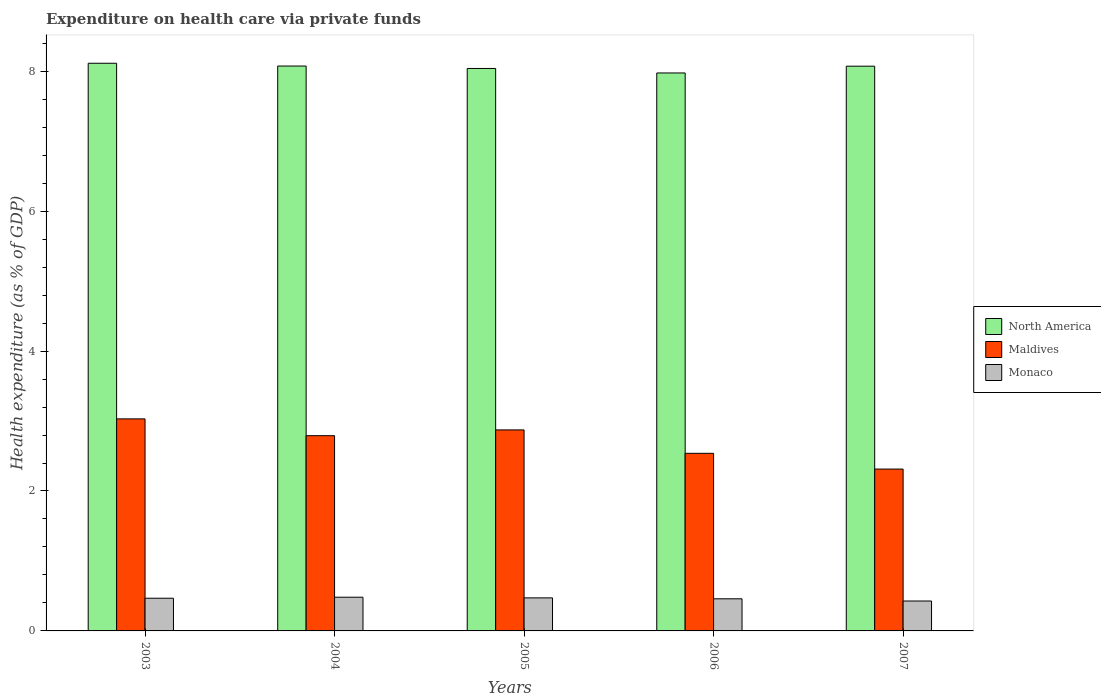How many groups of bars are there?
Make the answer very short. 5. Are the number of bars per tick equal to the number of legend labels?
Offer a terse response. Yes. How many bars are there on the 2nd tick from the left?
Offer a very short reply. 3. What is the expenditure made on health care in Maldives in 2004?
Your answer should be compact. 2.79. Across all years, what is the maximum expenditure made on health care in North America?
Provide a short and direct response. 8.11. Across all years, what is the minimum expenditure made on health care in Monaco?
Give a very brief answer. 0.43. What is the total expenditure made on health care in Monaco in the graph?
Your answer should be very brief. 2.31. What is the difference between the expenditure made on health care in Maldives in 2004 and that in 2007?
Offer a very short reply. 0.48. What is the difference between the expenditure made on health care in North America in 2003 and the expenditure made on health care in Monaco in 2004?
Keep it short and to the point. 7.63. What is the average expenditure made on health care in Maldives per year?
Give a very brief answer. 2.71. In the year 2004, what is the difference between the expenditure made on health care in North America and expenditure made on health care in Monaco?
Ensure brevity in your answer.  7.59. What is the ratio of the expenditure made on health care in Monaco in 2003 to that in 2005?
Make the answer very short. 0.99. Is the expenditure made on health care in Monaco in 2003 less than that in 2006?
Offer a very short reply. No. What is the difference between the highest and the second highest expenditure made on health care in Monaco?
Your answer should be compact. 0.01. What is the difference between the highest and the lowest expenditure made on health care in Monaco?
Make the answer very short. 0.05. In how many years, is the expenditure made on health care in North America greater than the average expenditure made on health care in North America taken over all years?
Your response must be concise. 3. What does the 2nd bar from the left in 2007 represents?
Provide a short and direct response. Maldives. What does the 1st bar from the right in 2006 represents?
Make the answer very short. Monaco. Are all the bars in the graph horizontal?
Your answer should be very brief. No. Does the graph contain any zero values?
Your answer should be compact. No. Where does the legend appear in the graph?
Make the answer very short. Center right. How are the legend labels stacked?
Provide a succinct answer. Vertical. What is the title of the graph?
Make the answer very short. Expenditure on health care via private funds. Does "Albania" appear as one of the legend labels in the graph?
Your response must be concise. No. What is the label or title of the X-axis?
Your answer should be compact. Years. What is the label or title of the Y-axis?
Keep it short and to the point. Health expenditure (as % of GDP). What is the Health expenditure (as % of GDP) of North America in 2003?
Your answer should be very brief. 8.11. What is the Health expenditure (as % of GDP) of Maldives in 2003?
Make the answer very short. 3.03. What is the Health expenditure (as % of GDP) of Monaco in 2003?
Provide a succinct answer. 0.47. What is the Health expenditure (as % of GDP) of North America in 2004?
Offer a very short reply. 8.07. What is the Health expenditure (as % of GDP) in Maldives in 2004?
Offer a very short reply. 2.79. What is the Health expenditure (as % of GDP) of Monaco in 2004?
Make the answer very short. 0.48. What is the Health expenditure (as % of GDP) in North America in 2005?
Offer a very short reply. 8.04. What is the Health expenditure (as % of GDP) in Maldives in 2005?
Offer a very short reply. 2.87. What is the Health expenditure (as % of GDP) of Monaco in 2005?
Ensure brevity in your answer.  0.47. What is the Health expenditure (as % of GDP) of North America in 2006?
Your answer should be very brief. 7.98. What is the Health expenditure (as % of GDP) in Maldives in 2006?
Offer a very short reply. 2.54. What is the Health expenditure (as % of GDP) of Monaco in 2006?
Provide a short and direct response. 0.46. What is the Health expenditure (as % of GDP) in North America in 2007?
Your response must be concise. 8.07. What is the Health expenditure (as % of GDP) in Maldives in 2007?
Offer a terse response. 2.31. What is the Health expenditure (as % of GDP) in Monaco in 2007?
Provide a succinct answer. 0.43. Across all years, what is the maximum Health expenditure (as % of GDP) of North America?
Keep it short and to the point. 8.11. Across all years, what is the maximum Health expenditure (as % of GDP) of Maldives?
Offer a terse response. 3.03. Across all years, what is the maximum Health expenditure (as % of GDP) in Monaco?
Provide a short and direct response. 0.48. Across all years, what is the minimum Health expenditure (as % of GDP) of North America?
Ensure brevity in your answer.  7.98. Across all years, what is the minimum Health expenditure (as % of GDP) of Maldives?
Provide a short and direct response. 2.31. Across all years, what is the minimum Health expenditure (as % of GDP) in Monaco?
Provide a succinct answer. 0.43. What is the total Health expenditure (as % of GDP) in North America in the graph?
Offer a very short reply. 40.27. What is the total Health expenditure (as % of GDP) of Maldives in the graph?
Keep it short and to the point. 13.55. What is the total Health expenditure (as % of GDP) in Monaco in the graph?
Ensure brevity in your answer.  2.31. What is the difference between the Health expenditure (as % of GDP) of North America in 2003 and that in 2004?
Offer a very short reply. 0.04. What is the difference between the Health expenditure (as % of GDP) in Maldives in 2003 and that in 2004?
Keep it short and to the point. 0.24. What is the difference between the Health expenditure (as % of GDP) of Monaco in 2003 and that in 2004?
Your answer should be compact. -0.01. What is the difference between the Health expenditure (as % of GDP) in North America in 2003 and that in 2005?
Your response must be concise. 0.07. What is the difference between the Health expenditure (as % of GDP) in Maldives in 2003 and that in 2005?
Provide a succinct answer. 0.16. What is the difference between the Health expenditure (as % of GDP) of Monaco in 2003 and that in 2005?
Your answer should be very brief. -0.01. What is the difference between the Health expenditure (as % of GDP) of North America in 2003 and that in 2006?
Your answer should be compact. 0.14. What is the difference between the Health expenditure (as % of GDP) of Maldives in 2003 and that in 2006?
Ensure brevity in your answer.  0.49. What is the difference between the Health expenditure (as % of GDP) in Monaco in 2003 and that in 2006?
Your answer should be very brief. 0.01. What is the difference between the Health expenditure (as % of GDP) of North America in 2003 and that in 2007?
Give a very brief answer. 0.04. What is the difference between the Health expenditure (as % of GDP) of Maldives in 2003 and that in 2007?
Offer a terse response. 0.72. What is the difference between the Health expenditure (as % of GDP) of Monaco in 2003 and that in 2007?
Your answer should be compact. 0.04. What is the difference between the Health expenditure (as % of GDP) of North America in 2004 and that in 2005?
Offer a very short reply. 0.03. What is the difference between the Health expenditure (as % of GDP) of Maldives in 2004 and that in 2005?
Provide a succinct answer. -0.08. What is the difference between the Health expenditure (as % of GDP) in Monaco in 2004 and that in 2005?
Offer a terse response. 0.01. What is the difference between the Health expenditure (as % of GDP) in North America in 2004 and that in 2006?
Keep it short and to the point. 0.1. What is the difference between the Health expenditure (as % of GDP) in Maldives in 2004 and that in 2006?
Ensure brevity in your answer.  0.25. What is the difference between the Health expenditure (as % of GDP) of Monaco in 2004 and that in 2006?
Offer a very short reply. 0.02. What is the difference between the Health expenditure (as % of GDP) in North America in 2004 and that in 2007?
Offer a terse response. 0. What is the difference between the Health expenditure (as % of GDP) in Maldives in 2004 and that in 2007?
Your answer should be compact. 0.48. What is the difference between the Health expenditure (as % of GDP) of Monaco in 2004 and that in 2007?
Provide a short and direct response. 0.05. What is the difference between the Health expenditure (as % of GDP) of North America in 2005 and that in 2006?
Give a very brief answer. 0.06. What is the difference between the Health expenditure (as % of GDP) of Maldives in 2005 and that in 2006?
Your answer should be compact. 0.33. What is the difference between the Health expenditure (as % of GDP) in Monaco in 2005 and that in 2006?
Offer a very short reply. 0.01. What is the difference between the Health expenditure (as % of GDP) in North America in 2005 and that in 2007?
Offer a terse response. -0.03. What is the difference between the Health expenditure (as % of GDP) in Maldives in 2005 and that in 2007?
Make the answer very short. 0.56. What is the difference between the Health expenditure (as % of GDP) in Monaco in 2005 and that in 2007?
Your response must be concise. 0.04. What is the difference between the Health expenditure (as % of GDP) of North America in 2006 and that in 2007?
Your answer should be very brief. -0.1. What is the difference between the Health expenditure (as % of GDP) of Maldives in 2006 and that in 2007?
Provide a succinct answer. 0.23. What is the difference between the Health expenditure (as % of GDP) in Monaco in 2006 and that in 2007?
Your response must be concise. 0.03. What is the difference between the Health expenditure (as % of GDP) in North America in 2003 and the Health expenditure (as % of GDP) in Maldives in 2004?
Offer a terse response. 5.32. What is the difference between the Health expenditure (as % of GDP) in North America in 2003 and the Health expenditure (as % of GDP) in Monaco in 2004?
Your response must be concise. 7.63. What is the difference between the Health expenditure (as % of GDP) of Maldives in 2003 and the Health expenditure (as % of GDP) of Monaco in 2004?
Offer a terse response. 2.55. What is the difference between the Health expenditure (as % of GDP) in North America in 2003 and the Health expenditure (as % of GDP) in Maldives in 2005?
Ensure brevity in your answer.  5.24. What is the difference between the Health expenditure (as % of GDP) in North America in 2003 and the Health expenditure (as % of GDP) in Monaco in 2005?
Provide a succinct answer. 7.64. What is the difference between the Health expenditure (as % of GDP) in Maldives in 2003 and the Health expenditure (as % of GDP) in Monaco in 2005?
Provide a succinct answer. 2.56. What is the difference between the Health expenditure (as % of GDP) in North America in 2003 and the Health expenditure (as % of GDP) in Maldives in 2006?
Provide a short and direct response. 5.58. What is the difference between the Health expenditure (as % of GDP) of North America in 2003 and the Health expenditure (as % of GDP) of Monaco in 2006?
Give a very brief answer. 7.65. What is the difference between the Health expenditure (as % of GDP) in Maldives in 2003 and the Health expenditure (as % of GDP) in Monaco in 2006?
Your answer should be compact. 2.57. What is the difference between the Health expenditure (as % of GDP) in North America in 2003 and the Health expenditure (as % of GDP) in Maldives in 2007?
Your answer should be very brief. 5.8. What is the difference between the Health expenditure (as % of GDP) of North America in 2003 and the Health expenditure (as % of GDP) of Monaco in 2007?
Make the answer very short. 7.69. What is the difference between the Health expenditure (as % of GDP) in Maldives in 2003 and the Health expenditure (as % of GDP) in Monaco in 2007?
Provide a succinct answer. 2.6. What is the difference between the Health expenditure (as % of GDP) in North America in 2004 and the Health expenditure (as % of GDP) in Maldives in 2005?
Your answer should be very brief. 5.2. What is the difference between the Health expenditure (as % of GDP) in North America in 2004 and the Health expenditure (as % of GDP) in Monaco in 2005?
Provide a succinct answer. 7.6. What is the difference between the Health expenditure (as % of GDP) in Maldives in 2004 and the Health expenditure (as % of GDP) in Monaco in 2005?
Provide a succinct answer. 2.32. What is the difference between the Health expenditure (as % of GDP) of North America in 2004 and the Health expenditure (as % of GDP) of Maldives in 2006?
Make the answer very short. 5.54. What is the difference between the Health expenditure (as % of GDP) in North America in 2004 and the Health expenditure (as % of GDP) in Monaco in 2006?
Your answer should be compact. 7.62. What is the difference between the Health expenditure (as % of GDP) of Maldives in 2004 and the Health expenditure (as % of GDP) of Monaco in 2006?
Offer a terse response. 2.33. What is the difference between the Health expenditure (as % of GDP) of North America in 2004 and the Health expenditure (as % of GDP) of Maldives in 2007?
Provide a short and direct response. 5.76. What is the difference between the Health expenditure (as % of GDP) in North America in 2004 and the Health expenditure (as % of GDP) in Monaco in 2007?
Your answer should be very brief. 7.65. What is the difference between the Health expenditure (as % of GDP) in Maldives in 2004 and the Health expenditure (as % of GDP) in Monaco in 2007?
Provide a short and direct response. 2.36. What is the difference between the Health expenditure (as % of GDP) of North America in 2005 and the Health expenditure (as % of GDP) of Maldives in 2006?
Offer a very short reply. 5.5. What is the difference between the Health expenditure (as % of GDP) in North America in 2005 and the Health expenditure (as % of GDP) in Monaco in 2006?
Your answer should be compact. 7.58. What is the difference between the Health expenditure (as % of GDP) of Maldives in 2005 and the Health expenditure (as % of GDP) of Monaco in 2006?
Your response must be concise. 2.41. What is the difference between the Health expenditure (as % of GDP) in North America in 2005 and the Health expenditure (as % of GDP) in Maldives in 2007?
Keep it short and to the point. 5.73. What is the difference between the Health expenditure (as % of GDP) in North America in 2005 and the Health expenditure (as % of GDP) in Monaco in 2007?
Give a very brief answer. 7.61. What is the difference between the Health expenditure (as % of GDP) in Maldives in 2005 and the Health expenditure (as % of GDP) in Monaco in 2007?
Your answer should be very brief. 2.45. What is the difference between the Health expenditure (as % of GDP) in North America in 2006 and the Health expenditure (as % of GDP) in Maldives in 2007?
Your answer should be compact. 5.66. What is the difference between the Health expenditure (as % of GDP) in North America in 2006 and the Health expenditure (as % of GDP) in Monaco in 2007?
Your answer should be very brief. 7.55. What is the difference between the Health expenditure (as % of GDP) of Maldives in 2006 and the Health expenditure (as % of GDP) of Monaco in 2007?
Keep it short and to the point. 2.11. What is the average Health expenditure (as % of GDP) of North America per year?
Keep it short and to the point. 8.05. What is the average Health expenditure (as % of GDP) in Maldives per year?
Offer a terse response. 2.71. What is the average Health expenditure (as % of GDP) of Monaco per year?
Your answer should be very brief. 0.46. In the year 2003, what is the difference between the Health expenditure (as % of GDP) of North America and Health expenditure (as % of GDP) of Maldives?
Ensure brevity in your answer.  5.08. In the year 2003, what is the difference between the Health expenditure (as % of GDP) in North America and Health expenditure (as % of GDP) in Monaco?
Your answer should be compact. 7.65. In the year 2003, what is the difference between the Health expenditure (as % of GDP) of Maldives and Health expenditure (as % of GDP) of Monaco?
Keep it short and to the point. 2.56. In the year 2004, what is the difference between the Health expenditure (as % of GDP) in North America and Health expenditure (as % of GDP) in Maldives?
Provide a succinct answer. 5.28. In the year 2004, what is the difference between the Health expenditure (as % of GDP) in North America and Health expenditure (as % of GDP) in Monaco?
Your answer should be very brief. 7.59. In the year 2004, what is the difference between the Health expenditure (as % of GDP) of Maldives and Health expenditure (as % of GDP) of Monaco?
Provide a succinct answer. 2.31. In the year 2005, what is the difference between the Health expenditure (as % of GDP) of North America and Health expenditure (as % of GDP) of Maldives?
Provide a short and direct response. 5.17. In the year 2005, what is the difference between the Health expenditure (as % of GDP) in North America and Health expenditure (as % of GDP) in Monaco?
Provide a succinct answer. 7.57. In the year 2005, what is the difference between the Health expenditure (as % of GDP) of Maldives and Health expenditure (as % of GDP) of Monaco?
Make the answer very short. 2.4. In the year 2006, what is the difference between the Health expenditure (as % of GDP) of North America and Health expenditure (as % of GDP) of Maldives?
Ensure brevity in your answer.  5.44. In the year 2006, what is the difference between the Health expenditure (as % of GDP) in North America and Health expenditure (as % of GDP) in Monaco?
Provide a short and direct response. 7.52. In the year 2006, what is the difference between the Health expenditure (as % of GDP) in Maldives and Health expenditure (as % of GDP) in Monaco?
Your answer should be very brief. 2.08. In the year 2007, what is the difference between the Health expenditure (as % of GDP) in North America and Health expenditure (as % of GDP) in Maldives?
Keep it short and to the point. 5.76. In the year 2007, what is the difference between the Health expenditure (as % of GDP) in North America and Health expenditure (as % of GDP) in Monaco?
Offer a very short reply. 7.64. In the year 2007, what is the difference between the Health expenditure (as % of GDP) of Maldives and Health expenditure (as % of GDP) of Monaco?
Your answer should be very brief. 1.89. What is the ratio of the Health expenditure (as % of GDP) in North America in 2003 to that in 2004?
Provide a short and direct response. 1. What is the ratio of the Health expenditure (as % of GDP) of Maldives in 2003 to that in 2004?
Provide a short and direct response. 1.09. What is the ratio of the Health expenditure (as % of GDP) in Monaco in 2003 to that in 2004?
Your response must be concise. 0.97. What is the ratio of the Health expenditure (as % of GDP) of North America in 2003 to that in 2005?
Offer a very short reply. 1.01. What is the ratio of the Health expenditure (as % of GDP) in Maldives in 2003 to that in 2005?
Your response must be concise. 1.05. What is the ratio of the Health expenditure (as % of GDP) in North America in 2003 to that in 2006?
Provide a short and direct response. 1.02. What is the ratio of the Health expenditure (as % of GDP) in Maldives in 2003 to that in 2006?
Give a very brief answer. 1.19. What is the ratio of the Health expenditure (as % of GDP) in Monaco in 2003 to that in 2006?
Ensure brevity in your answer.  1.02. What is the ratio of the Health expenditure (as % of GDP) in Maldives in 2003 to that in 2007?
Offer a very short reply. 1.31. What is the ratio of the Health expenditure (as % of GDP) of Monaco in 2003 to that in 2007?
Your answer should be compact. 1.09. What is the ratio of the Health expenditure (as % of GDP) in Maldives in 2004 to that in 2005?
Offer a terse response. 0.97. What is the ratio of the Health expenditure (as % of GDP) of Monaco in 2004 to that in 2005?
Your answer should be very brief. 1.02. What is the ratio of the Health expenditure (as % of GDP) of North America in 2004 to that in 2006?
Offer a very short reply. 1.01. What is the ratio of the Health expenditure (as % of GDP) of Maldives in 2004 to that in 2006?
Your answer should be very brief. 1.1. What is the ratio of the Health expenditure (as % of GDP) in Monaco in 2004 to that in 2006?
Your response must be concise. 1.05. What is the ratio of the Health expenditure (as % of GDP) in North America in 2004 to that in 2007?
Your response must be concise. 1. What is the ratio of the Health expenditure (as % of GDP) of Maldives in 2004 to that in 2007?
Your response must be concise. 1.21. What is the ratio of the Health expenditure (as % of GDP) in Monaco in 2004 to that in 2007?
Keep it short and to the point. 1.13. What is the ratio of the Health expenditure (as % of GDP) in Maldives in 2005 to that in 2006?
Provide a succinct answer. 1.13. What is the ratio of the Health expenditure (as % of GDP) in Monaco in 2005 to that in 2006?
Ensure brevity in your answer.  1.03. What is the ratio of the Health expenditure (as % of GDP) of North America in 2005 to that in 2007?
Offer a very short reply. 1. What is the ratio of the Health expenditure (as % of GDP) of Maldives in 2005 to that in 2007?
Provide a short and direct response. 1.24. What is the ratio of the Health expenditure (as % of GDP) of Monaco in 2005 to that in 2007?
Keep it short and to the point. 1.1. What is the ratio of the Health expenditure (as % of GDP) of North America in 2006 to that in 2007?
Your response must be concise. 0.99. What is the ratio of the Health expenditure (as % of GDP) in Maldives in 2006 to that in 2007?
Provide a succinct answer. 1.1. What is the ratio of the Health expenditure (as % of GDP) in Monaco in 2006 to that in 2007?
Your answer should be compact. 1.07. What is the difference between the highest and the second highest Health expenditure (as % of GDP) of North America?
Provide a short and direct response. 0.04. What is the difference between the highest and the second highest Health expenditure (as % of GDP) in Maldives?
Keep it short and to the point. 0.16. What is the difference between the highest and the second highest Health expenditure (as % of GDP) in Monaco?
Provide a succinct answer. 0.01. What is the difference between the highest and the lowest Health expenditure (as % of GDP) of North America?
Your answer should be very brief. 0.14. What is the difference between the highest and the lowest Health expenditure (as % of GDP) in Maldives?
Offer a terse response. 0.72. What is the difference between the highest and the lowest Health expenditure (as % of GDP) in Monaco?
Your response must be concise. 0.05. 